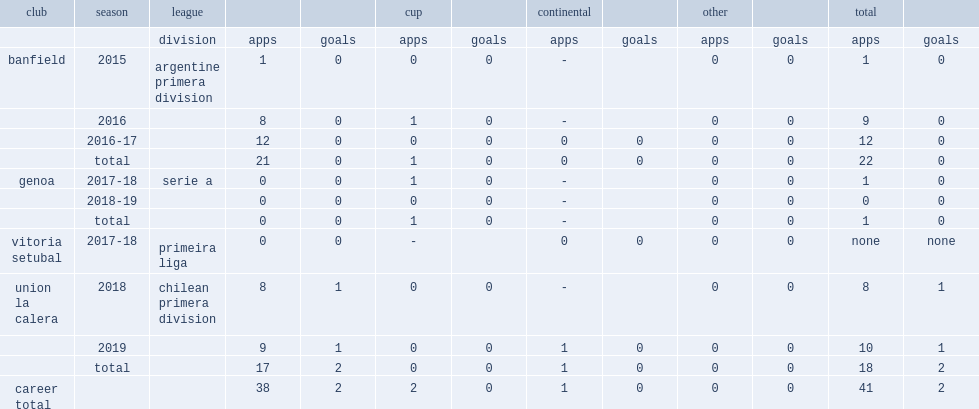In 2015, which league did thomas rodriguez debute for banfield? Argentine primera division. 